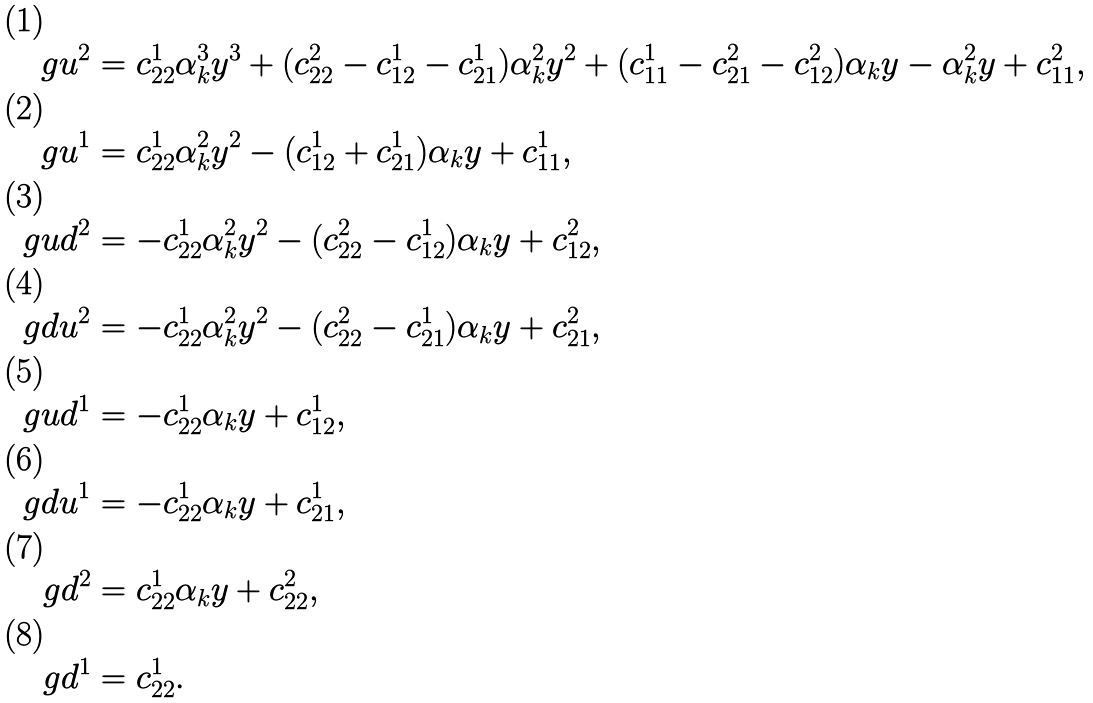Convert formula to latex. <formula><loc_0><loc_0><loc_500><loc_500>\ g u ^ { 2 } & = c _ { 2 2 } ^ { 1 } \alpha ^ { 3 } _ { k } y ^ { 3 } + ( c _ { 2 2 } ^ { 2 } - c _ { 1 2 } ^ { 1 } - c _ { 2 1 } ^ { 1 } ) \alpha ^ { 2 } _ { k } y ^ { 2 } + ( c _ { 1 1 } ^ { 1 } - c _ { 2 1 } ^ { 2 } - c _ { 1 2 } ^ { 2 } ) \alpha _ { k } y - \alpha ^ { 2 } _ { k } y + c _ { 1 1 } ^ { 2 } , \\ \ g u ^ { 1 } & = c _ { 2 2 } ^ { 1 } \alpha ^ { 2 } _ { k } y ^ { 2 } - ( c _ { 1 2 } ^ { 1 } + c _ { 2 1 } ^ { 1 } ) \alpha _ { k } y + c _ { 1 1 } ^ { 1 } , \\ \ g u d ^ { 2 } & = - c _ { 2 2 } ^ { 1 } \alpha ^ { 2 } _ { k } y ^ { 2 } - ( c _ { 2 2 } ^ { 2 } - c _ { 1 2 } ^ { 1 } ) \alpha _ { k } y + c _ { 1 2 } ^ { 2 } , \\ \ g d u ^ { 2 } & = - c _ { 2 2 } ^ { 1 } \alpha ^ { 2 } _ { k } y ^ { 2 } - ( c _ { 2 2 } ^ { 2 } - c _ { 2 1 } ^ { 1 } ) \alpha _ { k } y + c _ { 2 1 } ^ { 2 } , \\ \ g u d ^ { 1 } & = - c _ { 2 2 } ^ { 1 } \alpha _ { k } y + c _ { 1 2 } ^ { 1 } , \\ \ g d u ^ { 1 } & = - c _ { 2 2 } ^ { 1 } \alpha _ { k } y + c _ { 2 1 } ^ { 1 } , \\ \ g d ^ { 2 } & = c _ { 2 2 } ^ { 1 } \alpha _ { k } y + c _ { 2 2 } ^ { 2 } , \\ \ g d ^ { 1 } & = c _ { 2 2 } ^ { 1 } .</formula> 